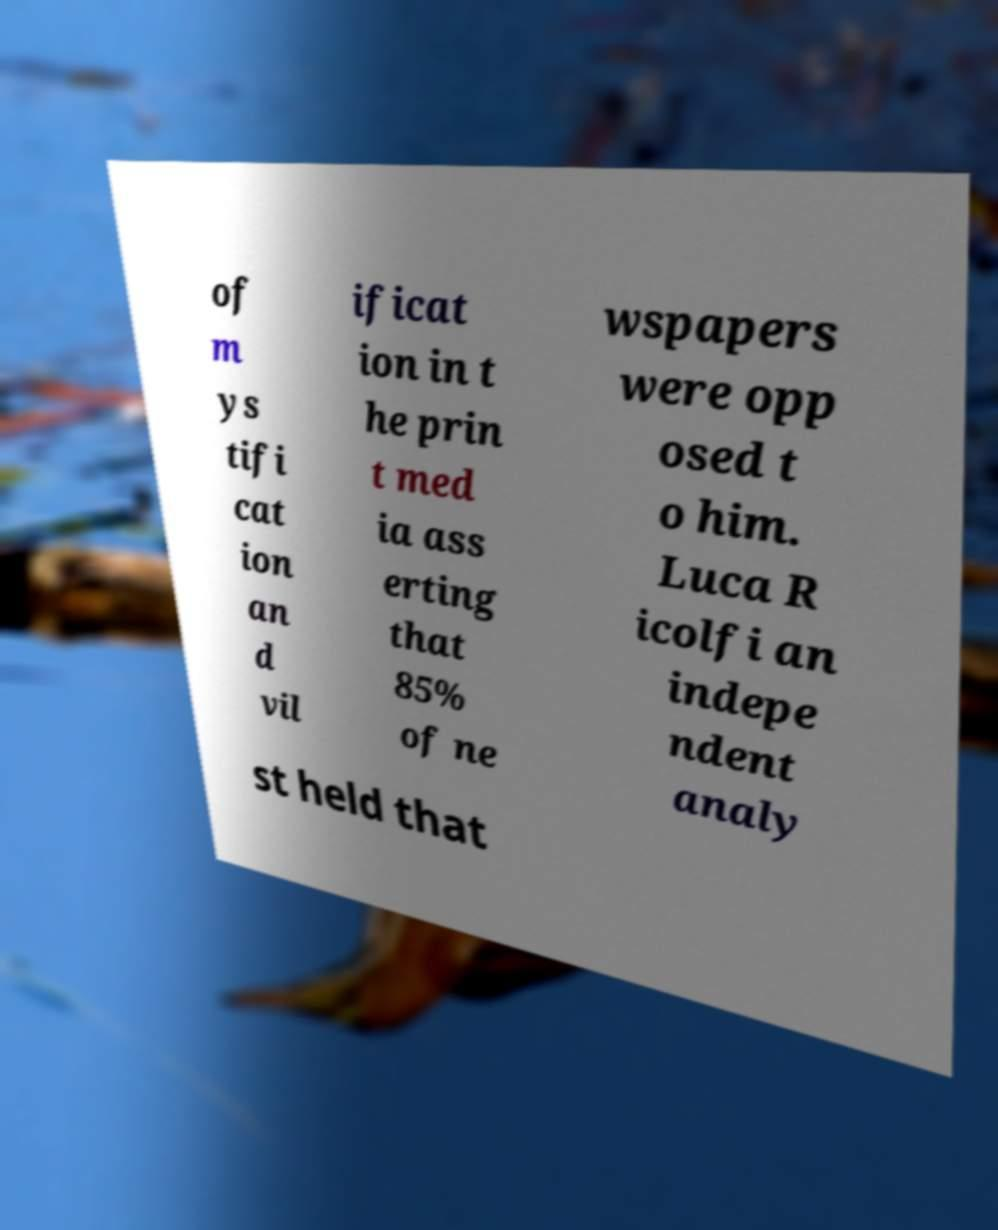Could you assist in decoding the text presented in this image and type it out clearly? of m ys tifi cat ion an d vil ificat ion in t he prin t med ia ass erting that 85% of ne wspapers were opp osed t o him. Luca R icolfi an indepe ndent analy st held that 